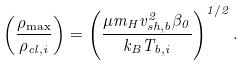Convert formula to latex. <formula><loc_0><loc_0><loc_500><loc_500>\left ( \frac { \rho _ { \max } } { \rho _ { c l , i } } \right ) = \left ( \frac { \mu m _ { H } v _ { s h , b } ^ { 2 } \beta _ { 0 } } { k _ { B } T _ { b , i } } \right ) ^ { 1 / 2 } .</formula> 